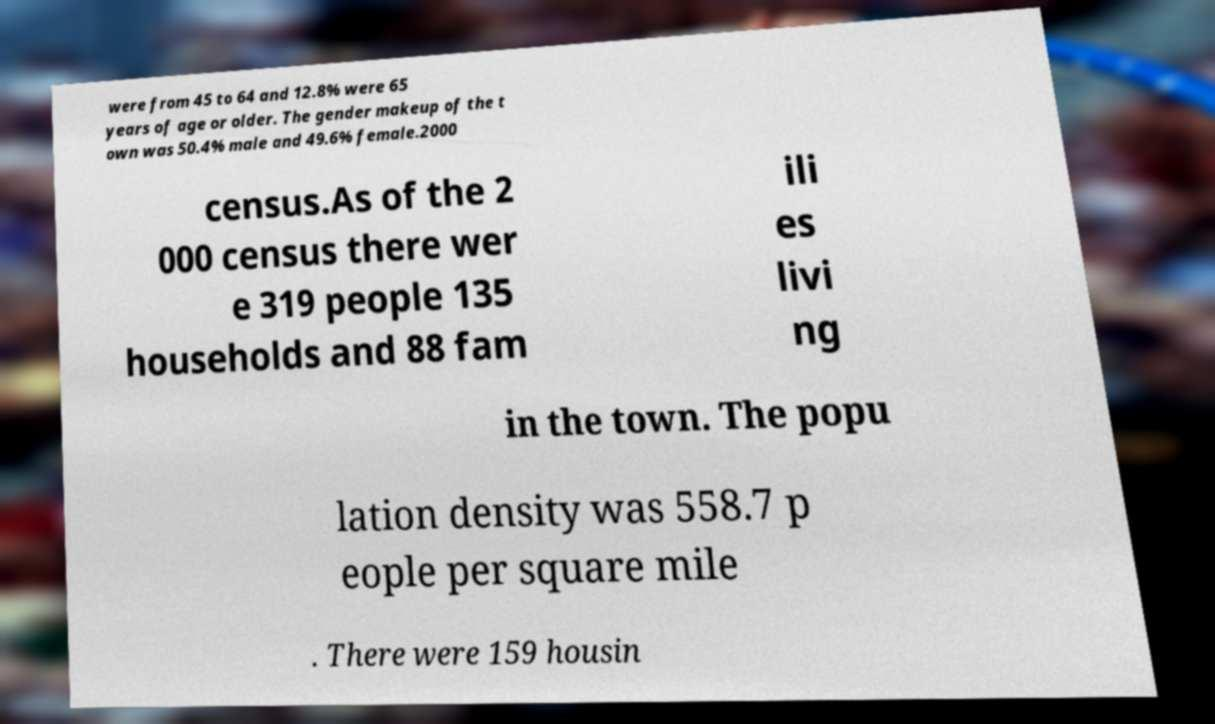I need the written content from this picture converted into text. Can you do that? were from 45 to 64 and 12.8% were 65 years of age or older. The gender makeup of the t own was 50.4% male and 49.6% female.2000 census.As of the 2 000 census there wer e 319 people 135 households and 88 fam ili es livi ng in the town. The popu lation density was 558.7 p eople per square mile . There were 159 housin 